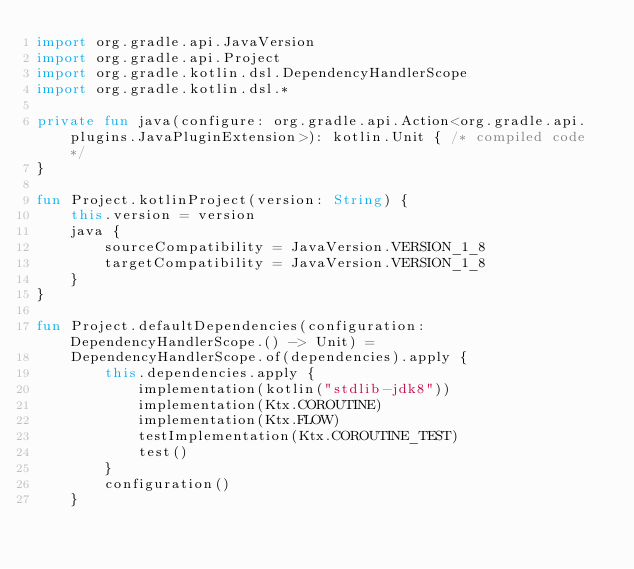Convert code to text. <code><loc_0><loc_0><loc_500><loc_500><_Kotlin_>import org.gradle.api.JavaVersion
import org.gradle.api.Project
import org.gradle.kotlin.dsl.DependencyHandlerScope
import org.gradle.kotlin.dsl.*

private fun java(configure: org.gradle.api.Action<org.gradle.api.plugins.JavaPluginExtension>): kotlin.Unit { /* compiled code */
}

fun Project.kotlinProject(version: String) {
    this.version = version
    java {
        sourceCompatibility = JavaVersion.VERSION_1_8
        targetCompatibility = JavaVersion.VERSION_1_8
    }
}

fun Project.defaultDependencies(configuration: DependencyHandlerScope.() -> Unit) =
    DependencyHandlerScope.of(dependencies).apply {
        this.dependencies.apply {
            implementation(kotlin("stdlib-jdk8"))
            implementation(Ktx.COROUTINE)
            implementation(Ktx.FLOW)
            testImplementation(Ktx.COROUTINE_TEST)
            test()
        }
        configuration()
    }

</code> 